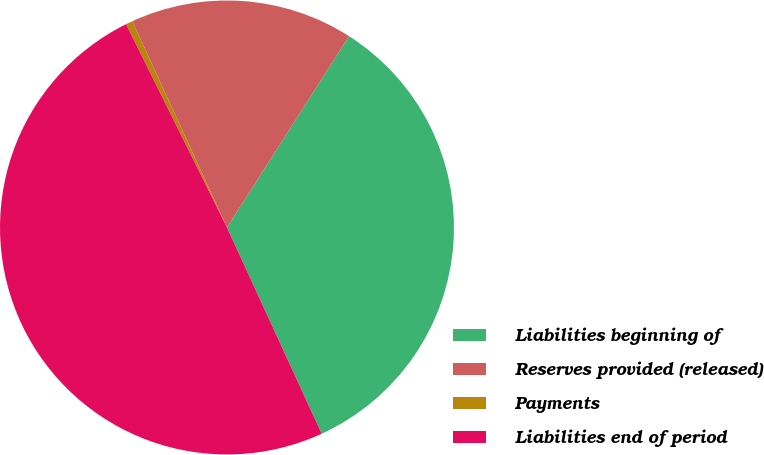Convert chart to OTSL. <chart><loc_0><loc_0><loc_500><loc_500><pie_chart><fcel>Liabilities beginning of<fcel>Reserves provided (released)<fcel>Payments<fcel>Liabilities end of period<nl><fcel>34.11%<fcel>15.89%<fcel>0.48%<fcel>49.52%<nl></chart> 